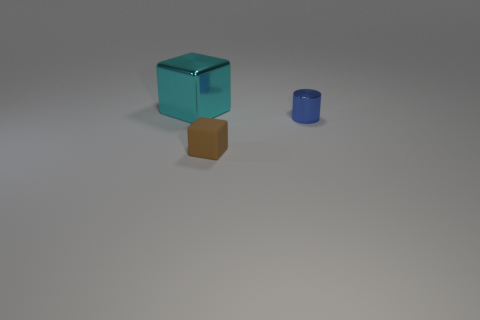There is a small thing right of the block that is to the right of the metal thing on the left side of the brown rubber cube; what color is it?
Provide a succinct answer. Blue. What number of spheres are matte objects or small things?
Offer a terse response. 0. What color is the matte block?
Keep it short and to the point. Brown. What number of objects are small yellow cubes or tiny brown rubber objects?
Offer a terse response. 1. There is a brown thing that is the same size as the cylinder; what is its material?
Make the answer very short. Rubber. How big is the cyan object that is behind the small brown rubber thing?
Offer a terse response. Large. What is the brown thing made of?
Ensure brevity in your answer.  Rubber. How many things are either things that are right of the matte cube or cubes that are to the right of the big cyan shiny block?
Ensure brevity in your answer.  2. How many other objects are the same color as the big object?
Keep it short and to the point. 0. There is a small brown matte thing; does it have the same shape as the metal object that is to the left of the blue thing?
Keep it short and to the point. Yes. 